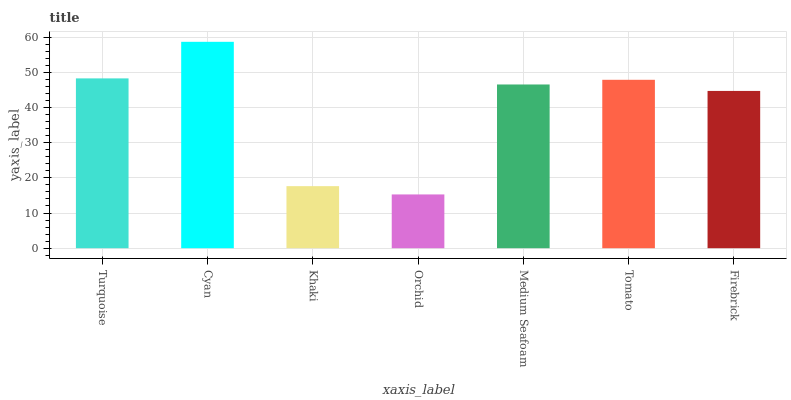Is Orchid the minimum?
Answer yes or no. Yes. Is Cyan the maximum?
Answer yes or no. Yes. Is Khaki the minimum?
Answer yes or no. No. Is Khaki the maximum?
Answer yes or no. No. Is Cyan greater than Khaki?
Answer yes or no. Yes. Is Khaki less than Cyan?
Answer yes or no. Yes. Is Khaki greater than Cyan?
Answer yes or no. No. Is Cyan less than Khaki?
Answer yes or no. No. Is Medium Seafoam the high median?
Answer yes or no. Yes. Is Medium Seafoam the low median?
Answer yes or no. Yes. Is Orchid the high median?
Answer yes or no. No. Is Tomato the low median?
Answer yes or no. No. 